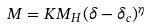<formula> <loc_0><loc_0><loc_500><loc_500>M = K M _ { H } ( \delta - \delta _ { c } ) ^ { \eta }</formula> 